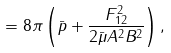Convert formula to latex. <formula><loc_0><loc_0><loc_500><loc_500>= 8 \pi \left ( \bar { p } + \frac { F ^ { 2 } _ { 1 2 } } { 2 \bar { \mu } A ^ { 2 } B ^ { 2 } } \right ) ,</formula> 